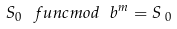Convert formula to latex. <formula><loc_0><loc_0><loc_500><loc_500>S _ { 0 } \ f u n c { m o d } \ b ^ { m } = S _ { \text { } 0 }</formula> 